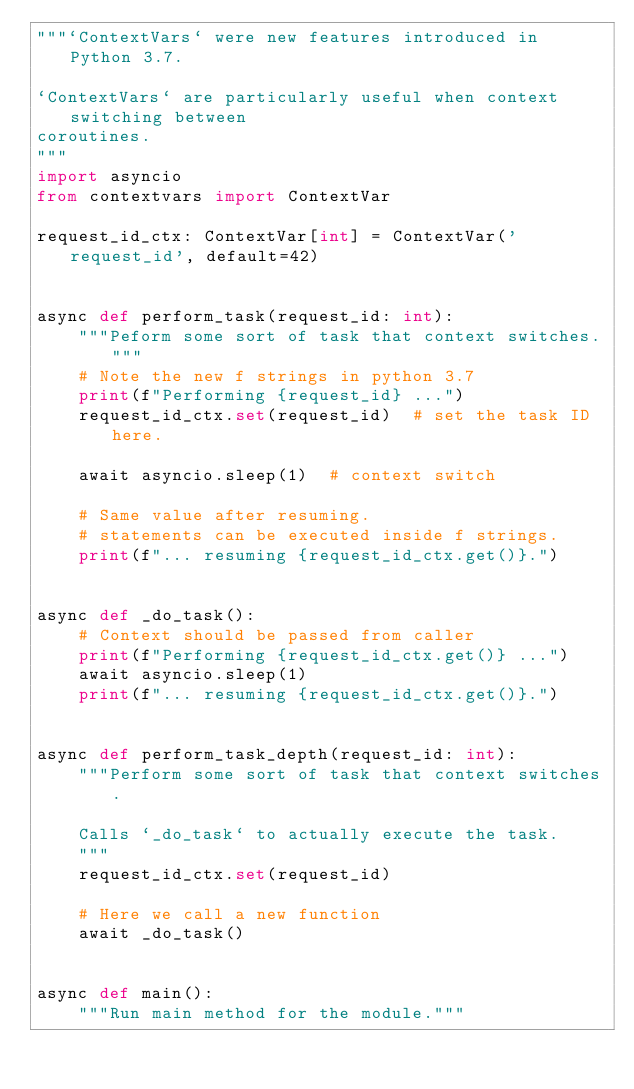Convert code to text. <code><loc_0><loc_0><loc_500><loc_500><_Python_>"""`ContextVars` were new features introduced in Python 3.7.

`ContextVars` are particularly useful when context switching between
coroutines.
"""
import asyncio
from contextvars import ContextVar

request_id_ctx: ContextVar[int] = ContextVar('request_id', default=42)


async def perform_task(request_id: int):
    """Peform some sort of task that context switches."""
    # Note the new f strings in python 3.7
    print(f"Performing {request_id} ...")
    request_id_ctx.set(request_id)  # set the task ID here.

    await asyncio.sleep(1)  # context switch

    # Same value after resuming.
    # statements can be executed inside f strings.
    print(f"... resuming {request_id_ctx.get()}.")


async def _do_task():
    # Context should be passed from caller
    print(f"Performing {request_id_ctx.get()} ...")
    await asyncio.sleep(1)
    print(f"... resuming {request_id_ctx.get()}.")


async def perform_task_depth(request_id: int):
    """Perform some sort of task that context switches.

    Calls `_do_task` to actually execute the task.
    """
    request_id_ctx.set(request_id)

    # Here we call a new function
    await _do_task()


async def main():
    """Run main method for the module."""</code> 